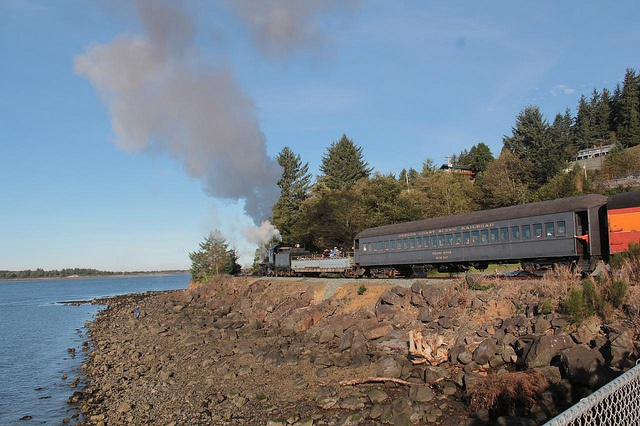Describe the objects in this image and their specific colors. I can see train in darkgray, gray, and black tones and people in darkgray, black, maroon, salmon, and red tones in this image. 